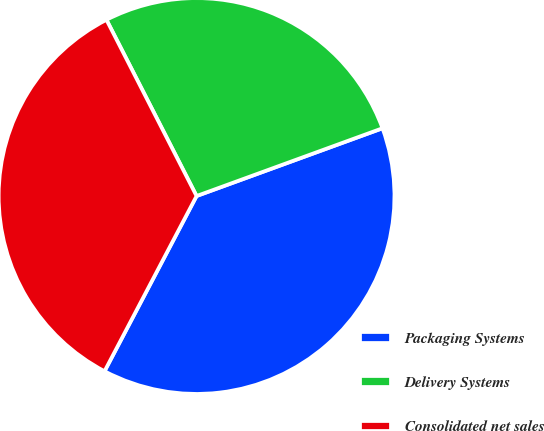Convert chart to OTSL. <chart><loc_0><loc_0><loc_500><loc_500><pie_chart><fcel>Packaging Systems<fcel>Delivery Systems<fcel>Consolidated net sales<nl><fcel>38.26%<fcel>26.96%<fcel>34.78%<nl></chart> 